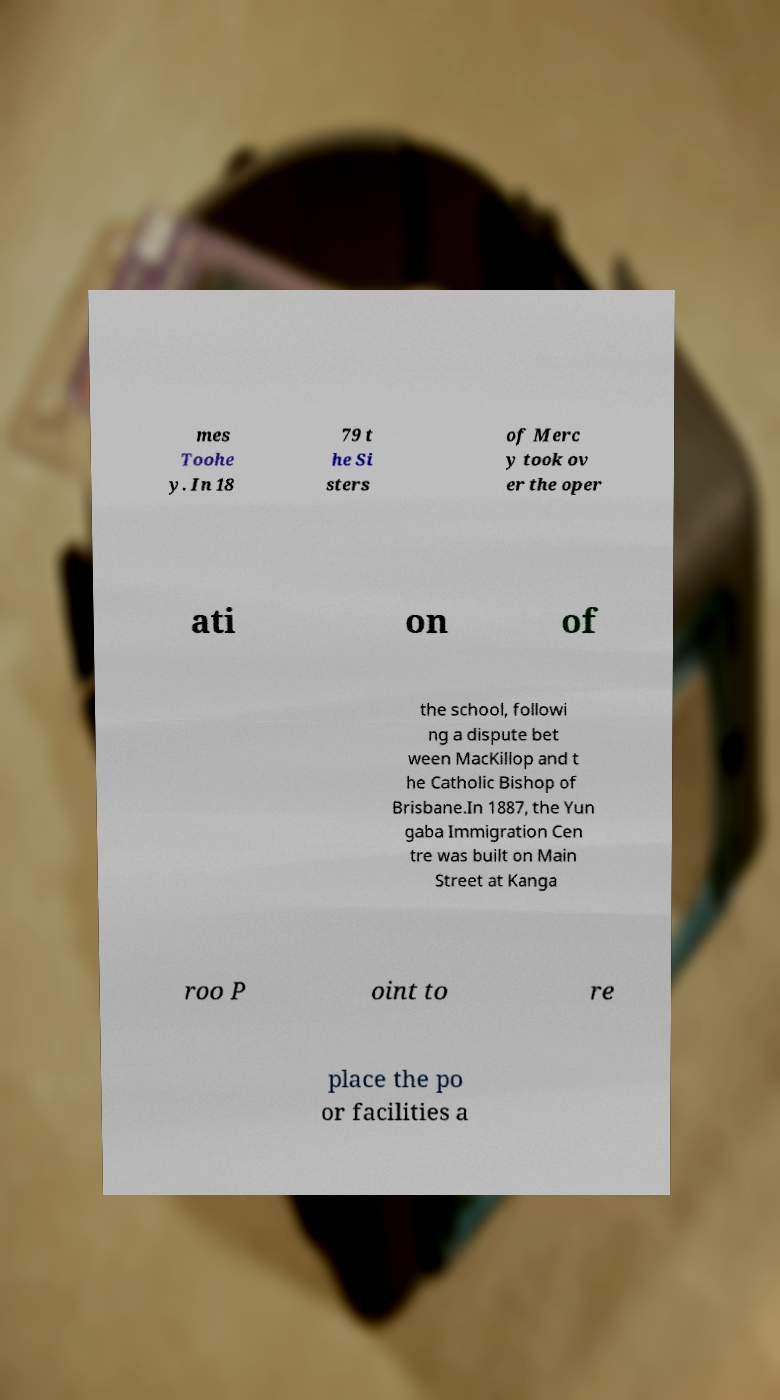Could you assist in decoding the text presented in this image and type it out clearly? mes Toohe y. In 18 79 t he Si sters of Merc y took ov er the oper ati on of the school, followi ng a dispute bet ween MacKillop and t he Catholic Bishop of Brisbane.In 1887, the Yun gaba Immigration Cen tre was built on Main Street at Kanga roo P oint to re place the po or facilities a 